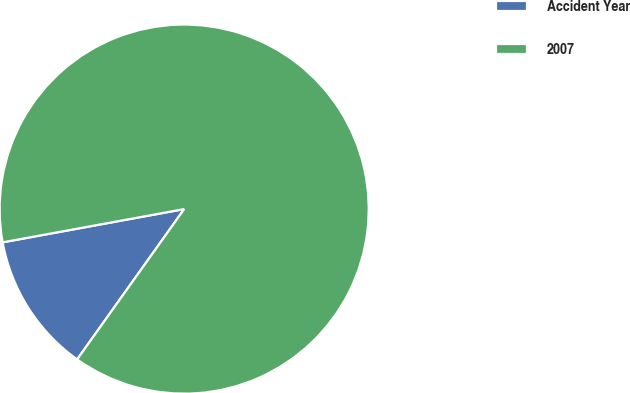Convert chart to OTSL. <chart><loc_0><loc_0><loc_500><loc_500><pie_chart><fcel>Accident Year<fcel>2007<nl><fcel>12.27%<fcel>87.73%<nl></chart> 